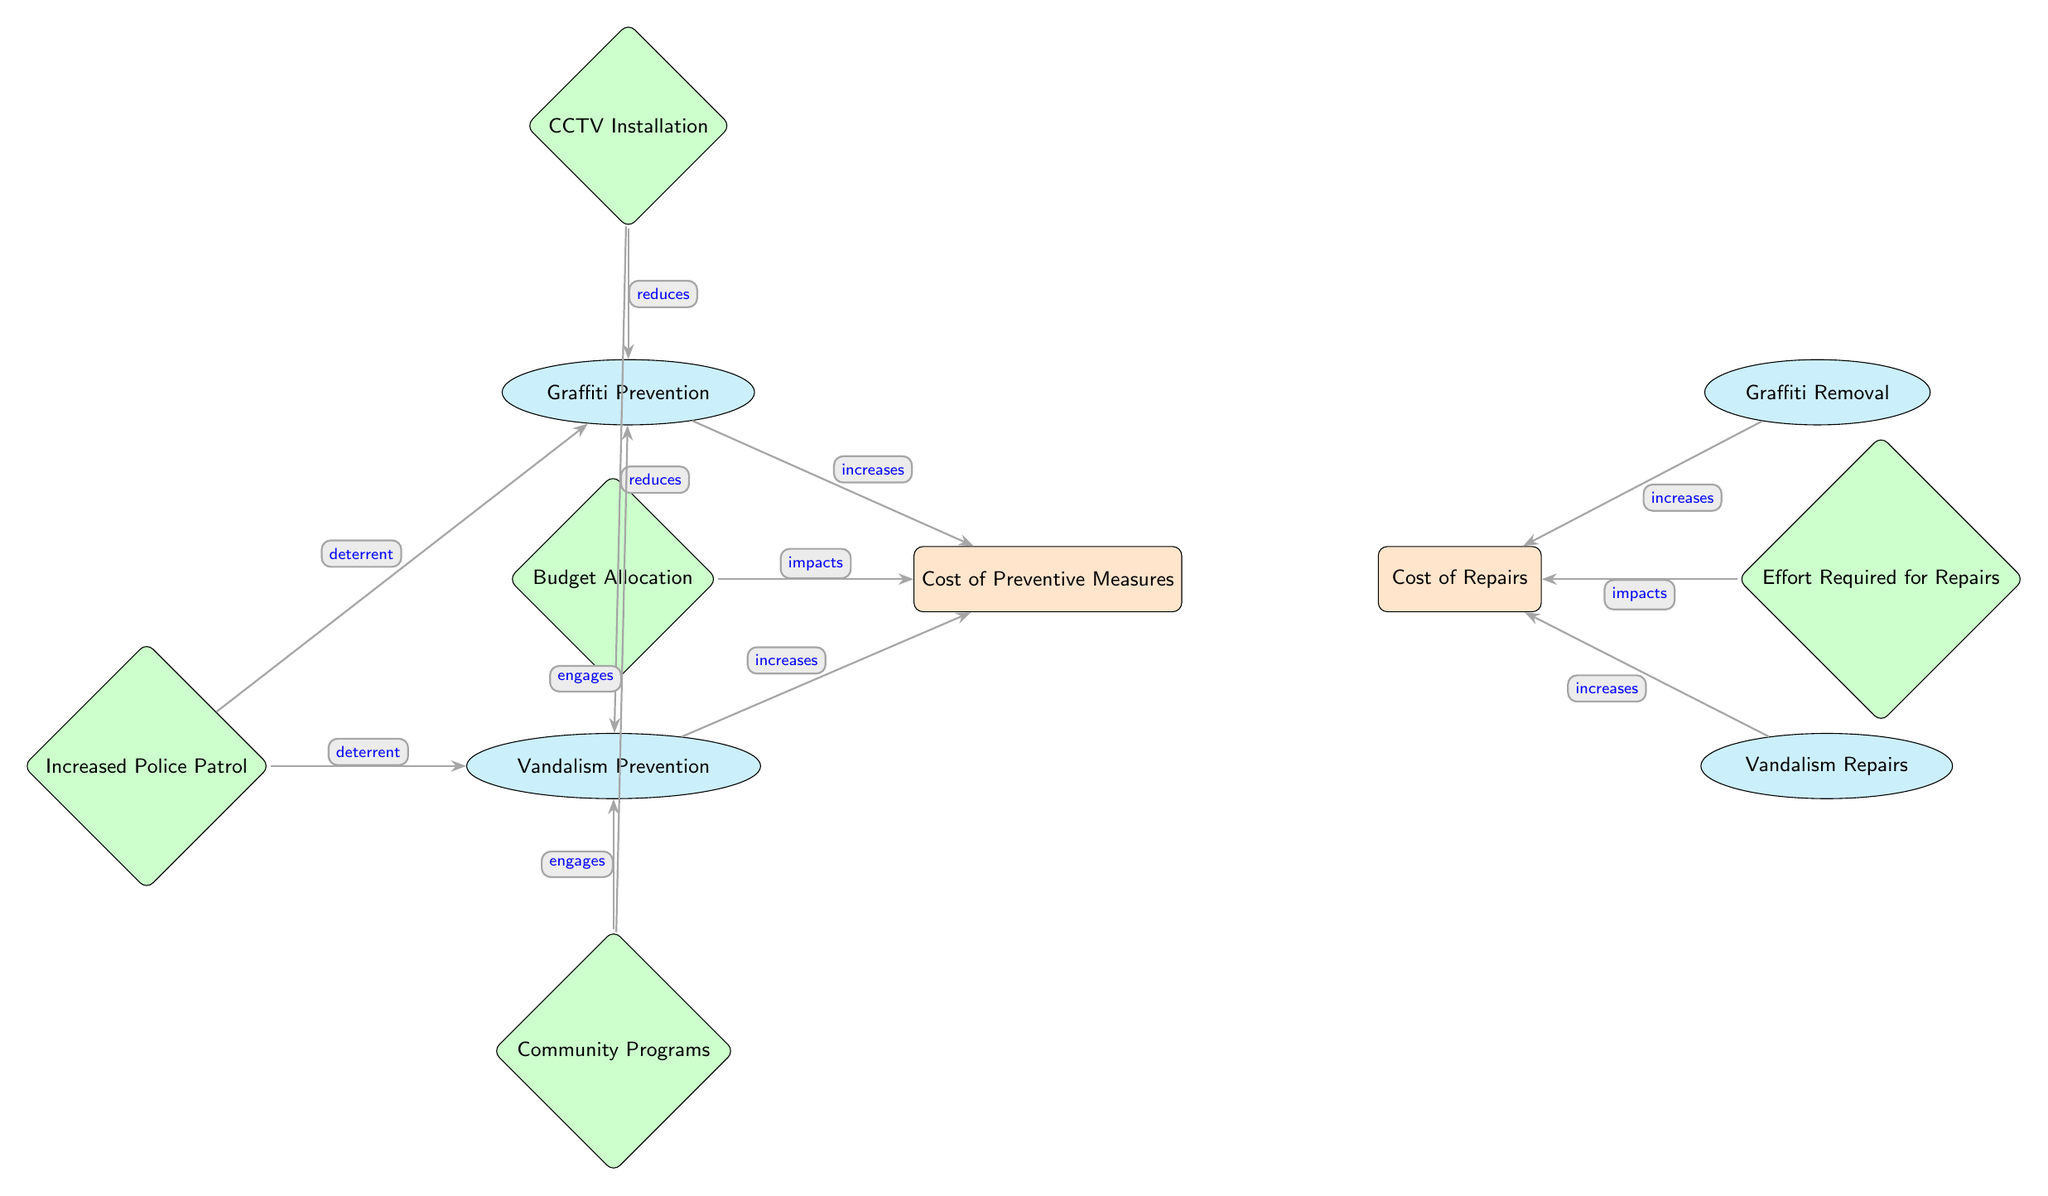What are the two main costs shown in the diagram? The diagram illustrates two main node categories: 'Cost of Preventive Measures' and 'Cost of Repairs'. These are positioned on the left and right of the diagram, respectively.
Answer: Cost of Preventive Measures, Cost of Repairs How many preventive measures are indicated in the diagram? The diagram lists two preventive measures located above and below the 'Cost of Preventive Measures' node: 'Graffiti Prevention' and 'Vandalism Prevention'. Thus, the count is two.
Answer: 2 What factor influences the 'Cost of Repairs'? The only factor indicated in the diagram directly associated with 'Cost of Repairs' is 'Effort Required for Repairs', positioned to the right of the 'Cost of Repairs' node.
Answer: Effort Required for Repairs Which preventive measure is connected to 'Increased Police Patrol'? The 'Increased Police Patrol' node is linked to both 'Graffiti Prevention' and 'Vandalism Prevention' through the notation 'deterrent', but since the question asks for one measure, either answer would be valid.
Answer: Graffiti Prevention What impact does 'CCTV Installation' have on preventive measures? 'CCTV Installation' is shown to 'reduce' the occurrences of both 'Graffiti Prevention' and 'Vandalism Prevention', as indicated by the arrows pointing towards these nodes. This implies that its installation actively contributes to the effectiveness of these preventive measures.
Answer: Reduces How do 'Community Programs' interact with preventive measures? 'Community Programs' are linked to both 'Graffiti Prevention' and 'Vandalism Prevention', indicated by the edges labeled ‘engages’, suggesting that these programs foster involvement or action toward mitigating the issues.
Answer: Engages Which preventive measure has the least direct cost contribution indicated in the diagram? The diagram shows that 'Cost of Preventive Measures' includes contributions from both preventive measures, but there's no indication of varying costs on the measures themselves. Due to their equal positioning without cost differentiation, we could infer that both contribute equally.
Answer: Both contribute equally Is there a direct edge connecting 'Budget Allocation' to 'Cost of Repairs'? No, 'Budget Allocation' is connected only to 'Cost of Preventive Measures' in the diagram, implying it does not directly influence repair costs in this model.
Answer: No What phrases describe the relationship between 'Police Patrol' and 'Vandalism Prevention'? The relationship is described as 'deterrent', indicating that the presence of increased police patrols is meant to prevent vandalism. This is stated clearly with an edge connecting these two nodes.
Answer: Deterrent 